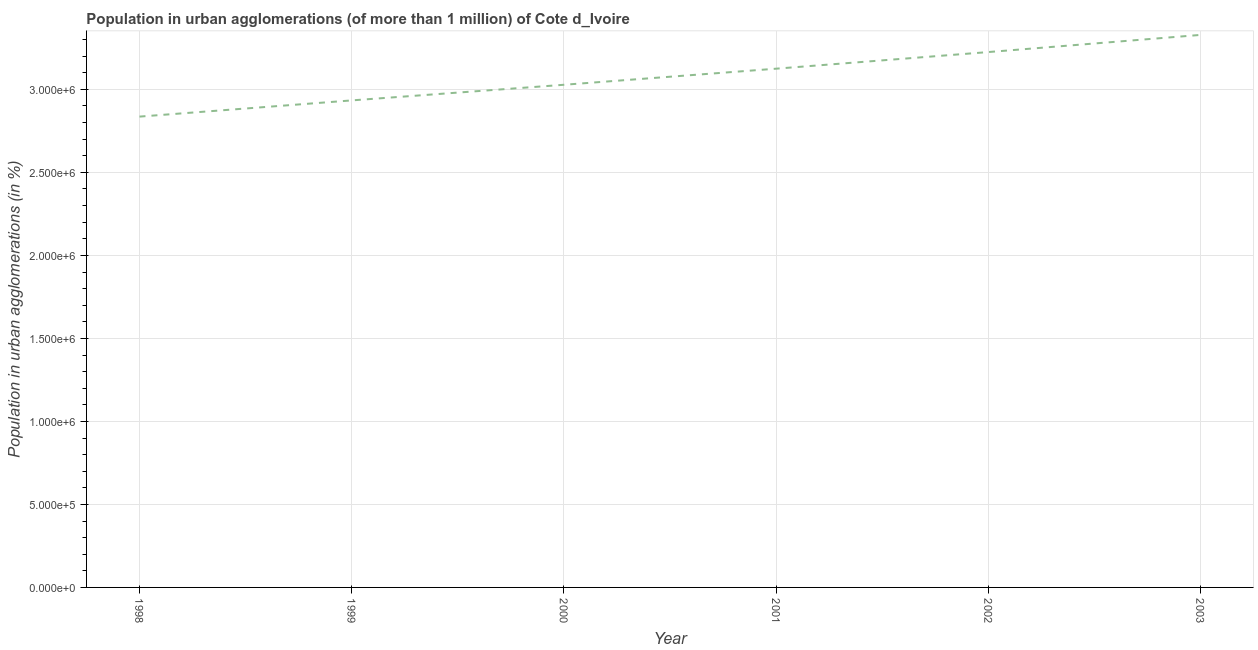What is the population in urban agglomerations in 2001?
Your answer should be compact. 3.12e+06. Across all years, what is the maximum population in urban agglomerations?
Offer a very short reply. 3.33e+06. Across all years, what is the minimum population in urban agglomerations?
Offer a terse response. 2.84e+06. In which year was the population in urban agglomerations minimum?
Offer a terse response. 1998. What is the sum of the population in urban agglomerations?
Make the answer very short. 1.85e+07. What is the difference between the population in urban agglomerations in 1999 and 2001?
Your answer should be compact. -1.91e+05. What is the average population in urban agglomerations per year?
Offer a terse response. 3.08e+06. What is the median population in urban agglomerations?
Offer a very short reply. 3.08e+06. In how many years, is the population in urban agglomerations greater than 2000000 %?
Your answer should be compact. 6. Do a majority of the years between 2000 and 2002 (inclusive) have population in urban agglomerations greater than 1000000 %?
Your answer should be very brief. Yes. What is the ratio of the population in urban agglomerations in 2001 to that in 2003?
Offer a terse response. 0.94. What is the difference between the highest and the second highest population in urban agglomerations?
Your answer should be compact. 1.03e+05. What is the difference between the highest and the lowest population in urban agglomerations?
Provide a short and direct response. 4.92e+05. In how many years, is the population in urban agglomerations greater than the average population in urban agglomerations taken over all years?
Your answer should be very brief. 3. How many lines are there?
Ensure brevity in your answer.  1. Are the values on the major ticks of Y-axis written in scientific E-notation?
Keep it short and to the point. Yes. What is the title of the graph?
Your answer should be very brief. Population in urban agglomerations (of more than 1 million) of Cote d_Ivoire. What is the label or title of the Y-axis?
Your response must be concise. Population in urban agglomerations (in %). What is the Population in urban agglomerations (in %) of 1998?
Keep it short and to the point. 2.84e+06. What is the Population in urban agglomerations (in %) in 1999?
Your answer should be compact. 2.93e+06. What is the Population in urban agglomerations (in %) in 2000?
Keep it short and to the point. 3.03e+06. What is the Population in urban agglomerations (in %) of 2001?
Your response must be concise. 3.12e+06. What is the Population in urban agglomerations (in %) in 2002?
Your response must be concise. 3.22e+06. What is the Population in urban agglomerations (in %) of 2003?
Your answer should be compact. 3.33e+06. What is the difference between the Population in urban agglomerations (in %) in 1998 and 1999?
Make the answer very short. -9.76e+04. What is the difference between the Population in urban agglomerations (in %) in 1998 and 2000?
Your answer should be very brief. -1.92e+05. What is the difference between the Population in urban agglomerations (in %) in 1998 and 2001?
Your answer should be very brief. -2.89e+05. What is the difference between the Population in urban agglomerations (in %) in 1998 and 2002?
Make the answer very short. -3.89e+05. What is the difference between the Population in urban agglomerations (in %) in 1998 and 2003?
Provide a short and direct response. -4.92e+05. What is the difference between the Population in urban agglomerations (in %) in 1999 and 2000?
Your answer should be compact. -9.41e+04. What is the difference between the Population in urban agglomerations (in %) in 1999 and 2001?
Your response must be concise. -1.91e+05. What is the difference between the Population in urban agglomerations (in %) in 1999 and 2002?
Ensure brevity in your answer.  -2.91e+05. What is the difference between the Population in urban agglomerations (in %) in 1999 and 2003?
Make the answer very short. -3.94e+05. What is the difference between the Population in urban agglomerations (in %) in 2000 and 2001?
Give a very brief answer. -9.69e+04. What is the difference between the Population in urban agglomerations (in %) in 2000 and 2002?
Provide a succinct answer. -1.97e+05. What is the difference between the Population in urban agglomerations (in %) in 2000 and 2003?
Keep it short and to the point. -3.00e+05. What is the difference between the Population in urban agglomerations (in %) in 2001 and 2002?
Provide a succinct answer. -1.00e+05. What is the difference between the Population in urban agglomerations (in %) in 2001 and 2003?
Offer a very short reply. -2.03e+05. What is the difference between the Population in urban agglomerations (in %) in 2002 and 2003?
Your response must be concise. -1.03e+05. What is the ratio of the Population in urban agglomerations (in %) in 1998 to that in 1999?
Ensure brevity in your answer.  0.97. What is the ratio of the Population in urban agglomerations (in %) in 1998 to that in 2000?
Keep it short and to the point. 0.94. What is the ratio of the Population in urban agglomerations (in %) in 1998 to that in 2001?
Offer a very short reply. 0.91. What is the ratio of the Population in urban agglomerations (in %) in 1998 to that in 2002?
Keep it short and to the point. 0.88. What is the ratio of the Population in urban agglomerations (in %) in 1998 to that in 2003?
Offer a terse response. 0.85. What is the ratio of the Population in urban agglomerations (in %) in 1999 to that in 2001?
Your answer should be very brief. 0.94. What is the ratio of the Population in urban agglomerations (in %) in 1999 to that in 2002?
Ensure brevity in your answer.  0.91. What is the ratio of the Population in urban agglomerations (in %) in 1999 to that in 2003?
Your response must be concise. 0.88. What is the ratio of the Population in urban agglomerations (in %) in 2000 to that in 2002?
Your response must be concise. 0.94. What is the ratio of the Population in urban agglomerations (in %) in 2000 to that in 2003?
Your response must be concise. 0.91. What is the ratio of the Population in urban agglomerations (in %) in 2001 to that in 2003?
Your response must be concise. 0.94. What is the ratio of the Population in urban agglomerations (in %) in 2002 to that in 2003?
Make the answer very short. 0.97. 